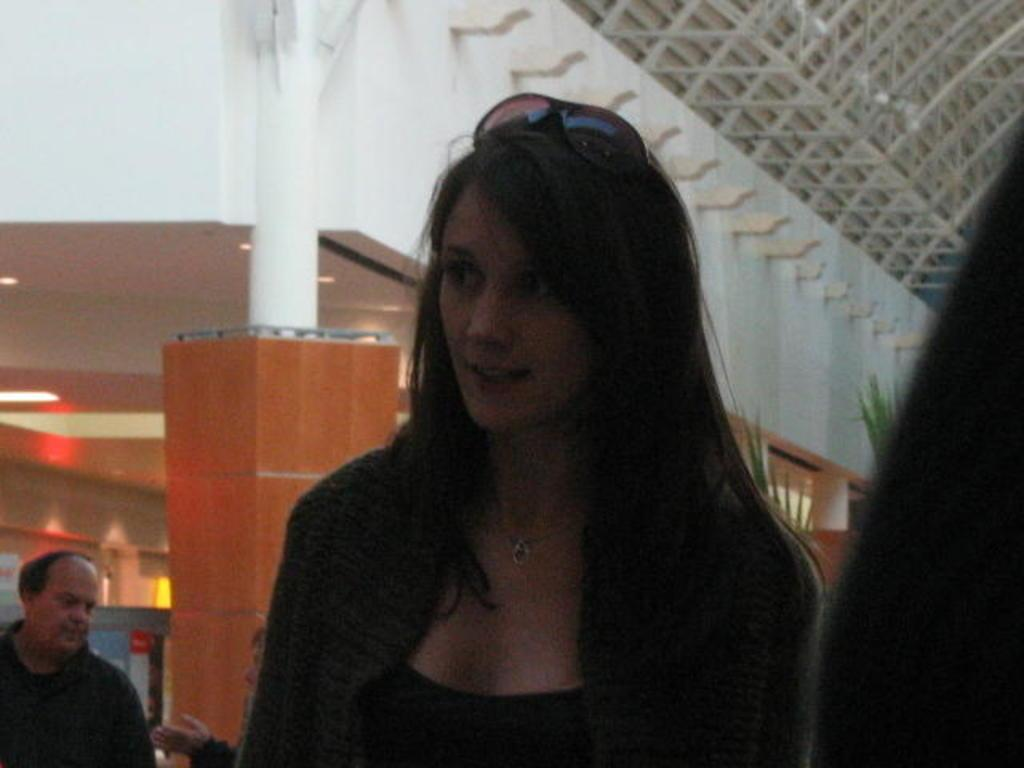Who is present in the image? There is a woman in the image. What can be seen in the background of the image? In the background, there are pillars, a ceiling, lights, walls, and rods. Where are the people and objects located in the image? The people and objects are on the left side of the image. What type of history is being taught by the woman in the image? There is no indication of any teaching or history in the image; it simply shows a woman in a particular setting. How many clocks are visible in the image? There are no clocks present in the image. 